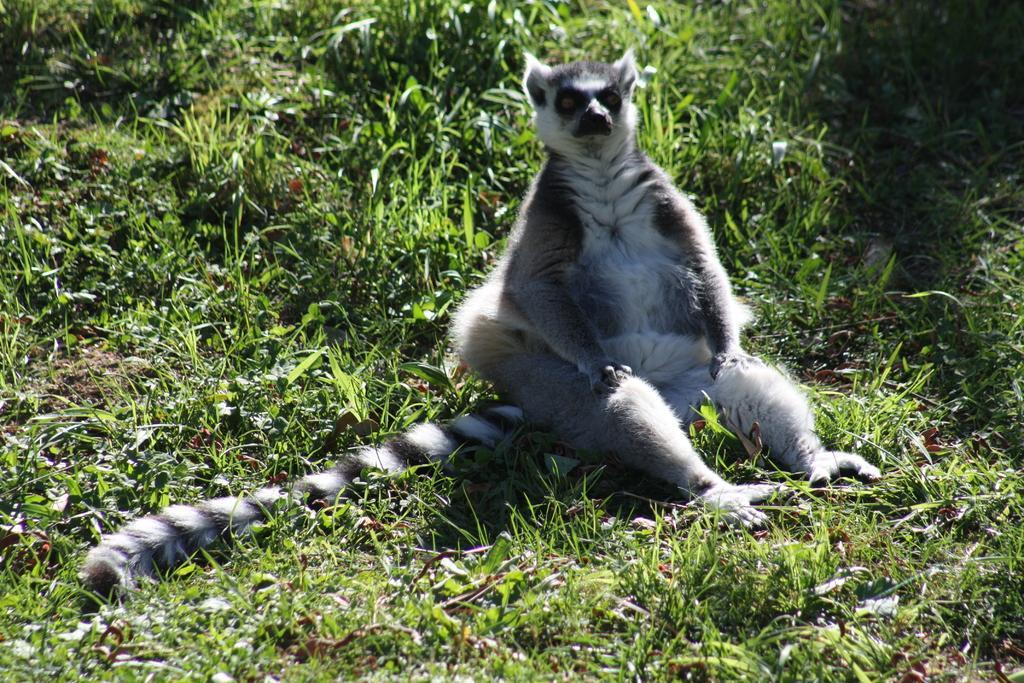Could you give a brief overview of what you see in this image? This image is taken outdoors. At the bottom of the image there is a ground with grass on it. In the middle of the image there is a Madagascar cat on the ground. It is with a big tail. 